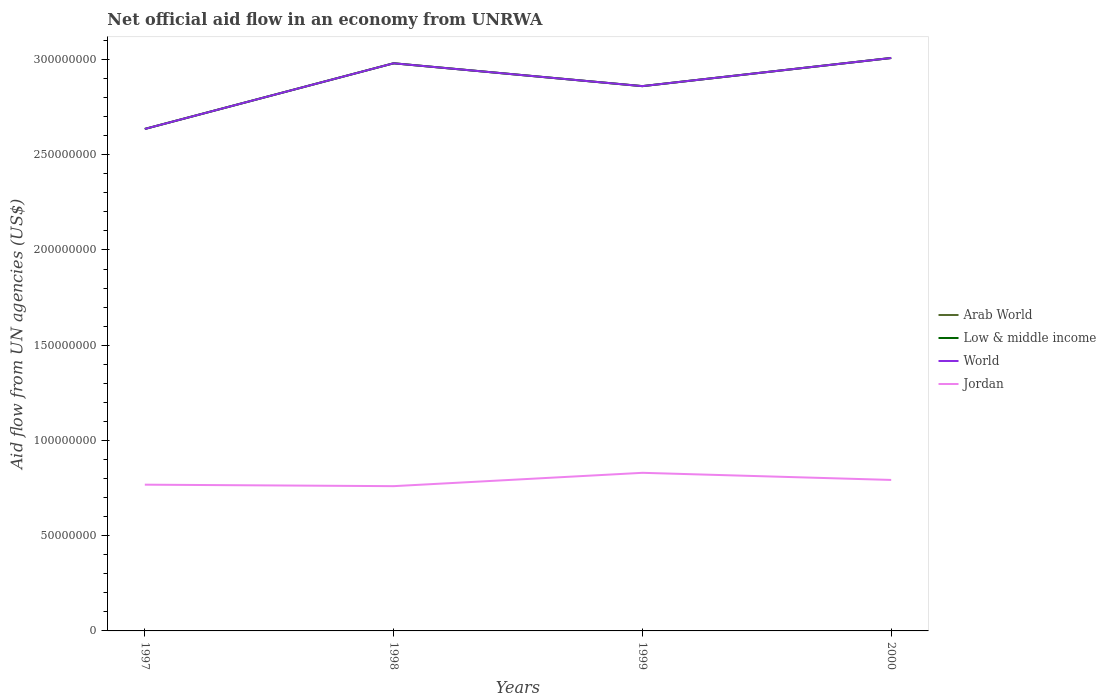Does the line corresponding to Jordan intersect with the line corresponding to Low & middle income?
Offer a very short reply. No. Across all years, what is the maximum net official aid flow in Jordan?
Offer a very short reply. 7.60e+07. In which year was the net official aid flow in Jordan maximum?
Provide a short and direct response. 1998. What is the difference between the highest and the second highest net official aid flow in Arab World?
Your answer should be very brief. 3.73e+07. Are the values on the major ticks of Y-axis written in scientific E-notation?
Offer a terse response. No. How are the legend labels stacked?
Make the answer very short. Vertical. What is the title of the graph?
Make the answer very short. Net official aid flow in an economy from UNRWA. Does "Libya" appear as one of the legend labels in the graph?
Offer a terse response. No. What is the label or title of the Y-axis?
Your response must be concise. Aid flow from UN agencies (US$). What is the Aid flow from UN agencies (US$) of Arab World in 1997?
Your answer should be compact. 2.64e+08. What is the Aid flow from UN agencies (US$) of Low & middle income in 1997?
Provide a succinct answer. 2.64e+08. What is the Aid flow from UN agencies (US$) of World in 1997?
Your response must be concise. 2.64e+08. What is the Aid flow from UN agencies (US$) of Jordan in 1997?
Ensure brevity in your answer.  7.68e+07. What is the Aid flow from UN agencies (US$) of Arab World in 1998?
Offer a terse response. 2.98e+08. What is the Aid flow from UN agencies (US$) in Low & middle income in 1998?
Give a very brief answer. 2.98e+08. What is the Aid flow from UN agencies (US$) in World in 1998?
Your answer should be very brief. 2.98e+08. What is the Aid flow from UN agencies (US$) of Jordan in 1998?
Make the answer very short. 7.60e+07. What is the Aid flow from UN agencies (US$) in Arab World in 1999?
Offer a terse response. 2.86e+08. What is the Aid flow from UN agencies (US$) in Low & middle income in 1999?
Your answer should be very brief. 2.86e+08. What is the Aid flow from UN agencies (US$) of World in 1999?
Provide a succinct answer. 2.86e+08. What is the Aid flow from UN agencies (US$) in Jordan in 1999?
Provide a short and direct response. 8.30e+07. What is the Aid flow from UN agencies (US$) in Arab World in 2000?
Ensure brevity in your answer.  3.01e+08. What is the Aid flow from UN agencies (US$) of Low & middle income in 2000?
Ensure brevity in your answer.  3.01e+08. What is the Aid flow from UN agencies (US$) in World in 2000?
Offer a terse response. 3.01e+08. What is the Aid flow from UN agencies (US$) in Jordan in 2000?
Your answer should be very brief. 7.93e+07. Across all years, what is the maximum Aid flow from UN agencies (US$) in Arab World?
Make the answer very short. 3.01e+08. Across all years, what is the maximum Aid flow from UN agencies (US$) of Low & middle income?
Provide a succinct answer. 3.01e+08. Across all years, what is the maximum Aid flow from UN agencies (US$) of World?
Make the answer very short. 3.01e+08. Across all years, what is the maximum Aid flow from UN agencies (US$) in Jordan?
Offer a very short reply. 8.30e+07. Across all years, what is the minimum Aid flow from UN agencies (US$) of Arab World?
Provide a short and direct response. 2.64e+08. Across all years, what is the minimum Aid flow from UN agencies (US$) in Low & middle income?
Keep it short and to the point. 2.64e+08. Across all years, what is the minimum Aid flow from UN agencies (US$) in World?
Make the answer very short. 2.64e+08. Across all years, what is the minimum Aid flow from UN agencies (US$) of Jordan?
Make the answer very short. 7.60e+07. What is the total Aid flow from UN agencies (US$) of Arab World in the graph?
Keep it short and to the point. 1.15e+09. What is the total Aid flow from UN agencies (US$) in Low & middle income in the graph?
Provide a succinct answer. 1.15e+09. What is the total Aid flow from UN agencies (US$) of World in the graph?
Ensure brevity in your answer.  1.15e+09. What is the total Aid flow from UN agencies (US$) in Jordan in the graph?
Your response must be concise. 3.15e+08. What is the difference between the Aid flow from UN agencies (US$) in Arab World in 1997 and that in 1998?
Your answer should be very brief. -3.45e+07. What is the difference between the Aid flow from UN agencies (US$) in Low & middle income in 1997 and that in 1998?
Give a very brief answer. -3.45e+07. What is the difference between the Aid flow from UN agencies (US$) in World in 1997 and that in 1998?
Provide a short and direct response. -3.45e+07. What is the difference between the Aid flow from UN agencies (US$) in Jordan in 1997 and that in 1998?
Your answer should be compact. 7.80e+05. What is the difference between the Aid flow from UN agencies (US$) in Arab World in 1997 and that in 1999?
Provide a succinct answer. -2.25e+07. What is the difference between the Aid flow from UN agencies (US$) of Low & middle income in 1997 and that in 1999?
Your answer should be compact. -2.25e+07. What is the difference between the Aid flow from UN agencies (US$) in World in 1997 and that in 1999?
Your response must be concise. -2.25e+07. What is the difference between the Aid flow from UN agencies (US$) in Jordan in 1997 and that in 1999?
Your answer should be very brief. -6.22e+06. What is the difference between the Aid flow from UN agencies (US$) in Arab World in 1997 and that in 2000?
Keep it short and to the point. -3.73e+07. What is the difference between the Aid flow from UN agencies (US$) in Low & middle income in 1997 and that in 2000?
Make the answer very short. -3.73e+07. What is the difference between the Aid flow from UN agencies (US$) of World in 1997 and that in 2000?
Ensure brevity in your answer.  -3.73e+07. What is the difference between the Aid flow from UN agencies (US$) of Jordan in 1997 and that in 2000?
Keep it short and to the point. -2.48e+06. What is the difference between the Aid flow from UN agencies (US$) of Arab World in 1998 and that in 1999?
Offer a terse response. 1.20e+07. What is the difference between the Aid flow from UN agencies (US$) of Jordan in 1998 and that in 1999?
Your answer should be very brief. -7.00e+06. What is the difference between the Aid flow from UN agencies (US$) in Arab World in 1998 and that in 2000?
Offer a terse response. -2.78e+06. What is the difference between the Aid flow from UN agencies (US$) in Low & middle income in 1998 and that in 2000?
Give a very brief answer. -2.78e+06. What is the difference between the Aid flow from UN agencies (US$) of World in 1998 and that in 2000?
Provide a succinct answer. -2.78e+06. What is the difference between the Aid flow from UN agencies (US$) in Jordan in 1998 and that in 2000?
Your answer should be compact. -3.26e+06. What is the difference between the Aid flow from UN agencies (US$) in Arab World in 1999 and that in 2000?
Provide a succinct answer. -1.48e+07. What is the difference between the Aid flow from UN agencies (US$) in Low & middle income in 1999 and that in 2000?
Provide a short and direct response. -1.48e+07. What is the difference between the Aid flow from UN agencies (US$) of World in 1999 and that in 2000?
Give a very brief answer. -1.48e+07. What is the difference between the Aid flow from UN agencies (US$) of Jordan in 1999 and that in 2000?
Keep it short and to the point. 3.74e+06. What is the difference between the Aid flow from UN agencies (US$) in Arab World in 1997 and the Aid flow from UN agencies (US$) in Low & middle income in 1998?
Your answer should be compact. -3.45e+07. What is the difference between the Aid flow from UN agencies (US$) of Arab World in 1997 and the Aid flow from UN agencies (US$) of World in 1998?
Your response must be concise. -3.45e+07. What is the difference between the Aid flow from UN agencies (US$) of Arab World in 1997 and the Aid flow from UN agencies (US$) of Jordan in 1998?
Your response must be concise. 1.88e+08. What is the difference between the Aid flow from UN agencies (US$) in Low & middle income in 1997 and the Aid flow from UN agencies (US$) in World in 1998?
Your answer should be compact. -3.45e+07. What is the difference between the Aid flow from UN agencies (US$) of Low & middle income in 1997 and the Aid flow from UN agencies (US$) of Jordan in 1998?
Provide a short and direct response. 1.88e+08. What is the difference between the Aid flow from UN agencies (US$) in World in 1997 and the Aid flow from UN agencies (US$) in Jordan in 1998?
Make the answer very short. 1.88e+08. What is the difference between the Aid flow from UN agencies (US$) in Arab World in 1997 and the Aid flow from UN agencies (US$) in Low & middle income in 1999?
Make the answer very short. -2.25e+07. What is the difference between the Aid flow from UN agencies (US$) in Arab World in 1997 and the Aid flow from UN agencies (US$) in World in 1999?
Ensure brevity in your answer.  -2.25e+07. What is the difference between the Aid flow from UN agencies (US$) in Arab World in 1997 and the Aid flow from UN agencies (US$) in Jordan in 1999?
Your answer should be very brief. 1.81e+08. What is the difference between the Aid flow from UN agencies (US$) of Low & middle income in 1997 and the Aid flow from UN agencies (US$) of World in 1999?
Offer a very short reply. -2.25e+07. What is the difference between the Aid flow from UN agencies (US$) in Low & middle income in 1997 and the Aid flow from UN agencies (US$) in Jordan in 1999?
Provide a short and direct response. 1.81e+08. What is the difference between the Aid flow from UN agencies (US$) in World in 1997 and the Aid flow from UN agencies (US$) in Jordan in 1999?
Your answer should be very brief. 1.81e+08. What is the difference between the Aid flow from UN agencies (US$) of Arab World in 1997 and the Aid flow from UN agencies (US$) of Low & middle income in 2000?
Give a very brief answer. -3.73e+07. What is the difference between the Aid flow from UN agencies (US$) in Arab World in 1997 and the Aid flow from UN agencies (US$) in World in 2000?
Provide a short and direct response. -3.73e+07. What is the difference between the Aid flow from UN agencies (US$) in Arab World in 1997 and the Aid flow from UN agencies (US$) in Jordan in 2000?
Your response must be concise. 1.84e+08. What is the difference between the Aid flow from UN agencies (US$) in Low & middle income in 1997 and the Aid flow from UN agencies (US$) in World in 2000?
Provide a short and direct response. -3.73e+07. What is the difference between the Aid flow from UN agencies (US$) of Low & middle income in 1997 and the Aid flow from UN agencies (US$) of Jordan in 2000?
Ensure brevity in your answer.  1.84e+08. What is the difference between the Aid flow from UN agencies (US$) in World in 1997 and the Aid flow from UN agencies (US$) in Jordan in 2000?
Ensure brevity in your answer.  1.84e+08. What is the difference between the Aid flow from UN agencies (US$) of Arab World in 1998 and the Aid flow from UN agencies (US$) of World in 1999?
Offer a terse response. 1.20e+07. What is the difference between the Aid flow from UN agencies (US$) in Arab World in 1998 and the Aid flow from UN agencies (US$) in Jordan in 1999?
Your answer should be very brief. 2.15e+08. What is the difference between the Aid flow from UN agencies (US$) in Low & middle income in 1998 and the Aid flow from UN agencies (US$) in World in 1999?
Provide a succinct answer. 1.20e+07. What is the difference between the Aid flow from UN agencies (US$) of Low & middle income in 1998 and the Aid flow from UN agencies (US$) of Jordan in 1999?
Provide a succinct answer. 2.15e+08. What is the difference between the Aid flow from UN agencies (US$) in World in 1998 and the Aid flow from UN agencies (US$) in Jordan in 1999?
Offer a terse response. 2.15e+08. What is the difference between the Aid flow from UN agencies (US$) in Arab World in 1998 and the Aid flow from UN agencies (US$) in Low & middle income in 2000?
Offer a very short reply. -2.78e+06. What is the difference between the Aid flow from UN agencies (US$) in Arab World in 1998 and the Aid flow from UN agencies (US$) in World in 2000?
Provide a succinct answer. -2.78e+06. What is the difference between the Aid flow from UN agencies (US$) of Arab World in 1998 and the Aid flow from UN agencies (US$) of Jordan in 2000?
Offer a very short reply. 2.19e+08. What is the difference between the Aid flow from UN agencies (US$) in Low & middle income in 1998 and the Aid flow from UN agencies (US$) in World in 2000?
Make the answer very short. -2.78e+06. What is the difference between the Aid flow from UN agencies (US$) in Low & middle income in 1998 and the Aid flow from UN agencies (US$) in Jordan in 2000?
Your answer should be very brief. 2.19e+08. What is the difference between the Aid flow from UN agencies (US$) in World in 1998 and the Aid flow from UN agencies (US$) in Jordan in 2000?
Make the answer very short. 2.19e+08. What is the difference between the Aid flow from UN agencies (US$) of Arab World in 1999 and the Aid flow from UN agencies (US$) of Low & middle income in 2000?
Your answer should be very brief. -1.48e+07. What is the difference between the Aid flow from UN agencies (US$) of Arab World in 1999 and the Aid flow from UN agencies (US$) of World in 2000?
Offer a very short reply. -1.48e+07. What is the difference between the Aid flow from UN agencies (US$) of Arab World in 1999 and the Aid flow from UN agencies (US$) of Jordan in 2000?
Your response must be concise. 2.07e+08. What is the difference between the Aid flow from UN agencies (US$) of Low & middle income in 1999 and the Aid flow from UN agencies (US$) of World in 2000?
Provide a short and direct response. -1.48e+07. What is the difference between the Aid flow from UN agencies (US$) in Low & middle income in 1999 and the Aid flow from UN agencies (US$) in Jordan in 2000?
Give a very brief answer. 2.07e+08. What is the difference between the Aid flow from UN agencies (US$) of World in 1999 and the Aid flow from UN agencies (US$) of Jordan in 2000?
Provide a short and direct response. 2.07e+08. What is the average Aid flow from UN agencies (US$) in Arab World per year?
Ensure brevity in your answer.  2.87e+08. What is the average Aid flow from UN agencies (US$) of Low & middle income per year?
Provide a short and direct response. 2.87e+08. What is the average Aid flow from UN agencies (US$) of World per year?
Your answer should be very brief. 2.87e+08. What is the average Aid flow from UN agencies (US$) in Jordan per year?
Offer a terse response. 7.88e+07. In the year 1997, what is the difference between the Aid flow from UN agencies (US$) in Arab World and Aid flow from UN agencies (US$) in World?
Offer a very short reply. 0. In the year 1997, what is the difference between the Aid flow from UN agencies (US$) in Arab World and Aid flow from UN agencies (US$) in Jordan?
Offer a terse response. 1.87e+08. In the year 1997, what is the difference between the Aid flow from UN agencies (US$) in Low & middle income and Aid flow from UN agencies (US$) in World?
Make the answer very short. 0. In the year 1997, what is the difference between the Aid flow from UN agencies (US$) of Low & middle income and Aid flow from UN agencies (US$) of Jordan?
Give a very brief answer. 1.87e+08. In the year 1997, what is the difference between the Aid flow from UN agencies (US$) of World and Aid flow from UN agencies (US$) of Jordan?
Offer a very short reply. 1.87e+08. In the year 1998, what is the difference between the Aid flow from UN agencies (US$) in Arab World and Aid flow from UN agencies (US$) in Low & middle income?
Ensure brevity in your answer.  0. In the year 1998, what is the difference between the Aid flow from UN agencies (US$) in Arab World and Aid flow from UN agencies (US$) in World?
Offer a terse response. 0. In the year 1998, what is the difference between the Aid flow from UN agencies (US$) of Arab World and Aid flow from UN agencies (US$) of Jordan?
Offer a very short reply. 2.22e+08. In the year 1998, what is the difference between the Aid flow from UN agencies (US$) in Low & middle income and Aid flow from UN agencies (US$) in Jordan?
Your answer should be very brief. 2.22e+08. In the year 1998, what is the difference between the Aid flow from UN agencies (US$) in World and Aid flow from UN agencies (US$) in Jordan?
Give a very brief answer. 2.22e+08. In the year 1999, what is the difference between the Aid flow from UN agencies (US$) of Arab World and Aid flow from UN agencies (US$) of Jordan?
Your answer should be very brief. 2.03e+08. In the year 1999, what is the difference between the Aid flow from UN agencies (US$) of Low & middle income and Aid flow from UN agencies (US$) of World?
Provide a short and direct response. 0. In the year 1999, what is the difference between the Aid flow from UN agencies (US$) in Low & middle income and Aid flow from UN agencies (US$) in Jordan?
Offer a very short reply. 2.03e+08. In the year 1999, what is the difference between the Aid flow from UN agencies (US$) in World and Aid flow from UN agencies (US$) in Jordan?
Provide a short and direct response. 2.03e+08. In the year 2000, what is the difference between the Aid flow from UN agencies (US$) in Arab World and Aid flow from UN agencies (US$) in World?
Offer a very short reply. 0. In the year 2000, what is the difference between the Aid flow from UN agencies (US$) in Arab World and Aid flow from UN agencies (US$) in Jordan?
Provide a succinct answer. 2.22e+08. In the year 2000, what is the difference between the Aid flow from UN agencies (US$) of Low & middle income and Aid flow from UN agencies (US$) of Jordan?
Your response must be concise. 2.22e+08. In the year 2000, what is the difference between the Aid flow from UN agencies (US$) of World and Aid flow from UN agencies (US$) of Jordan?
Keep it short and to the point. 2.22e+08. What is the ratio of the Aid flow from UN agencies (US$) of Arab World in 1997 to that in 1998?
Offer a very short reply. 0.88. What is the ratio of the Aid flow from UN agencies (US$) in Low & middle income in 1997 to that in 1998?
Make the answer very short. 0.88. What is the ratio of the Aid flow from UN agencies (US$) of World in 1997 to that in 1998?
Offer a terse response. 0.88. What is the ratio of the Aid flow from UN agencies (US$) in Jordan in 1997 to that in 1998?
Your answer should be very brief. 1.01. What is the ratio of the Aid flow from UN agencies (US$) in Arab World in 1997 to that in 1999?
Give a very brief answer. 0.92. What is the ratio of the Aid flow from UN agencies (US$) in Low & middle income in 1997 to that in 1999?
Provide a short and direct response. 0.92. What is the ratio of the Aid flow from UN agencies (US$) in World in 1997 to that in 1999?
Your response must be concise. 0.92. What is the ratio of the Aid flow from UN agencies (US$) of Jordan in 1997 to that in 1999?
Offer a terse response. 0.93. What is the ratio of the Aid flow from UN agencies (US$) in Arab World in 1997 to that in 2000?
Provide a succinct answer. 0.88. What is the ratio of the Aid flow from UN agencies (US$) in Low & middle income in 1997 to that in 2000?
Provide a succinct answer. 0.88. What is the ratio of the Aid flow from UN agencies (US$) in World in 1997 to that in 2000?
Offer a terse response. 0.88. What is the ratio of the Aid flow from UN agencies (US$) in Jordan in 1997 to that in 2000?
Provide a short and direct response. 0.97. What is the ratio of the Aid flow from UN agencies (US$) in Arab World in 1998 to that in 1999?
Make the answer very short. 1.04. What is the ratio of the Aid flow from UN agencies (US$) in Low & middle income in 1998 to that in 1999?
Ensure brevity in your answer.  1.04. What is the ratio of the Aid flow from UN agencies (US$) in World in 1998 to that in 1999?
Ensure brevity in your answer.  1.04. What is the ratio of the Aid flow from UN agencies (US$) in Jordan in 1998 to that in 1999?
Your answer should be compact. 0.92. What is the ratio of the Aid flow from UN agencies (US$) of Low & middle income in 1998 to that in 2000?
Offer a very short reply. 0.99. What is the ratio of the Aid flow from UN agencies (US$) in World in 1998 to that in 2000?
Ensure brevity in your answer.  0.99. What is the ratio of the Aid flow from UN agencies (US$) of Jordan in 1998 to that in 2000?
Your answer should be compact. 0.96. What is the ratio of the Aid flow from UN agencies (US$) of Arab World in 1999 to that in 2000?
Your answer should be very brief. 0.95. What is the ratio of the Aid flow from UN agencies (US$) of Low & middle income in 1999 to that in 2000?
Your answer should be compact. 0.95. What is the ratio of the Aid flow from UN agencies (US$) of World in 1999 to that in 2000?
Give a very brief answer. 0.95. What is the ratio of the Aid flow from UN agencies (US$) of Jordan in 1999 to that in 2000?
Provide a succinct answer. 1.05. What is the difference between the highest and the second highest Aid flow from UN agencies (US$) in Arab World?
Your answer should be compact. 2.78e+06. What is the difference between the highest and the second highest Aid flow from UN agencies (US$) in Low & middle income?
Make the answer very short. 2.78e+06. What is the difference between the highest and the second highest Aid flow from UN agencies (US$) of World?
Provide a short and direct response. 2.78e+06. What is the difference between the highest and the second highest Aid flow from UN agencies (US$) in Jordan?
Your answer should be compact. 3.74e+06. What is the difference between the highest and the lowest Aid flow from UN agencies (US$) in Arab World?
Your response must be concise. 3.73e+07. What is the difference between the highest and the lowest Aid flow from UN agencies (US$) in Low & middle income?
Your answer should be very brief. 3.73e+07. What is the difference between the highest and the lowest Aid flow from UN agencies (US$) of World?
Give a very brief answer. 3.73e+07. 